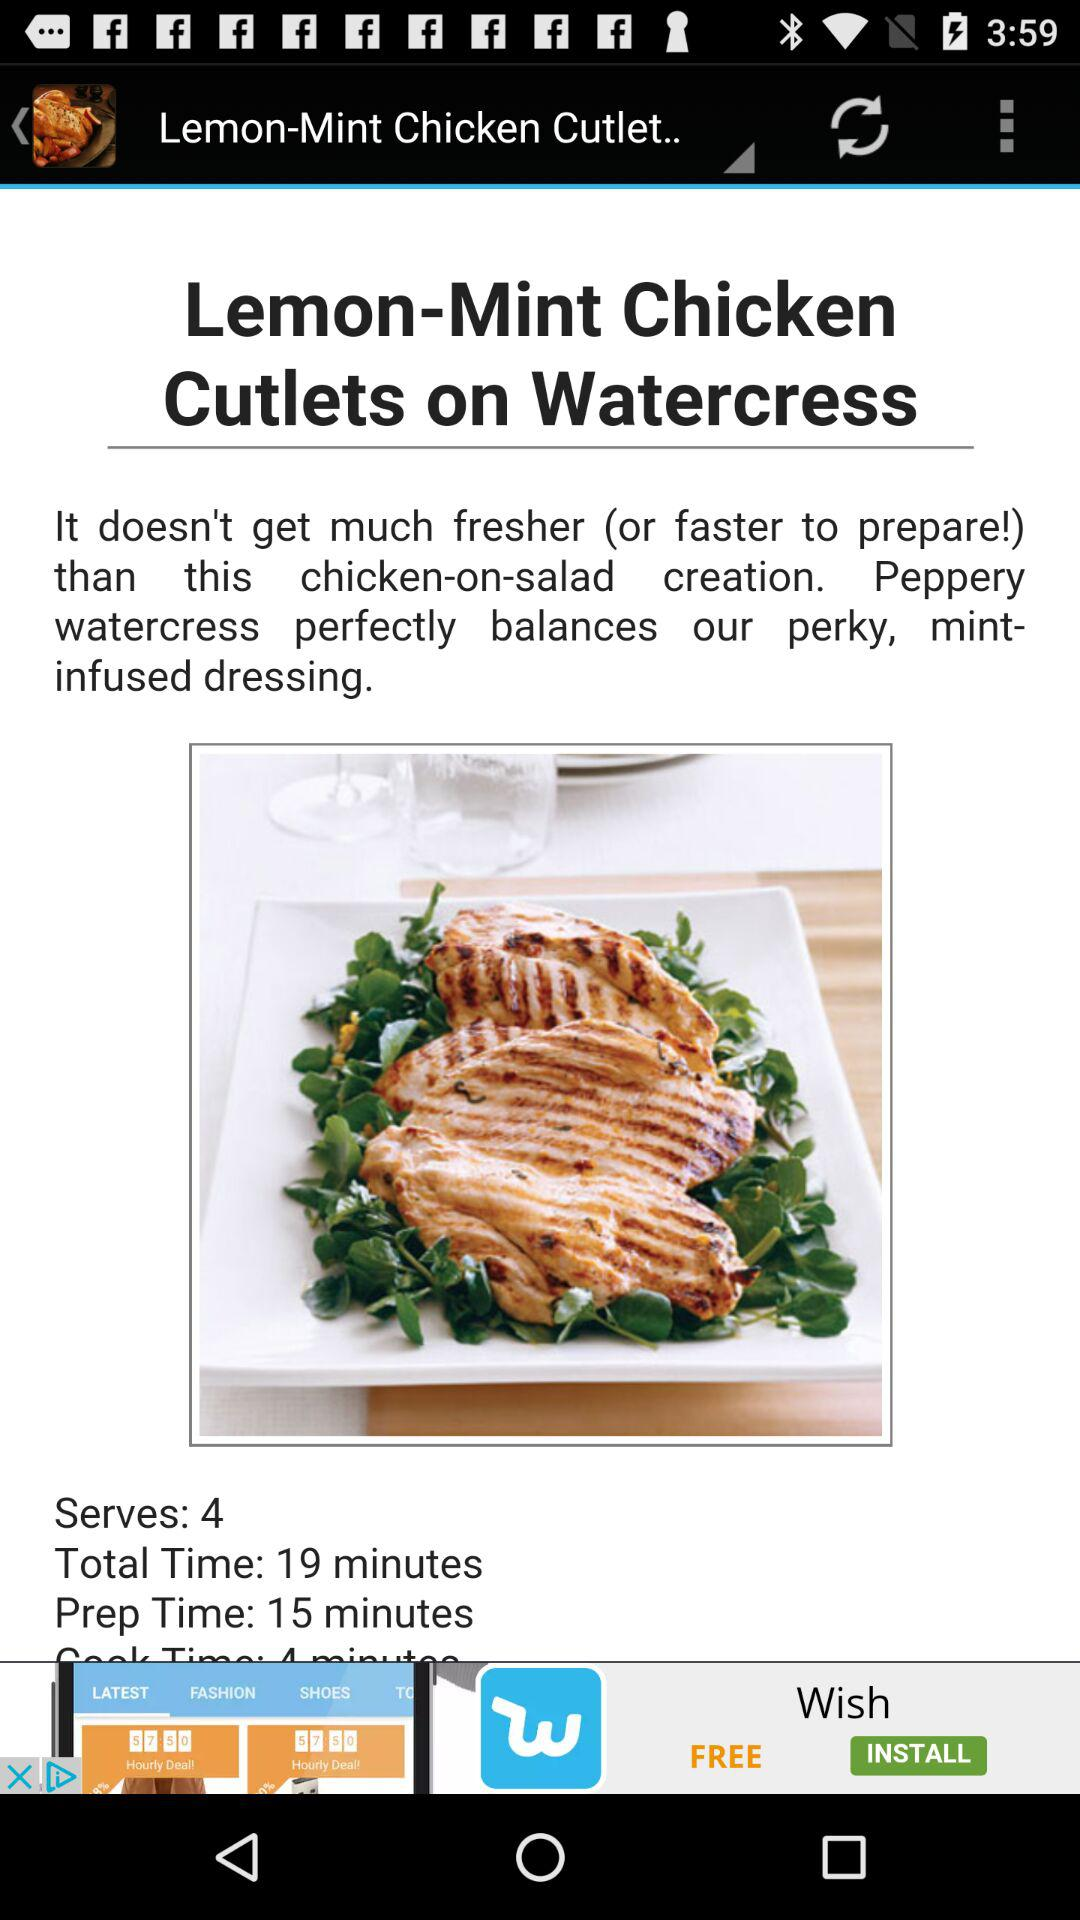How many people can the dish be served to? The dish can be served to 4 people. 